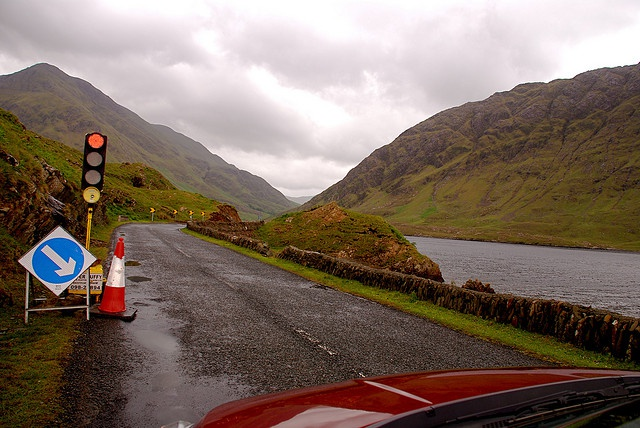Describe the objects in this image and their specific colors. I can see car in darkgray, maroon, black, brown, and gray tones and traffic light in darkgray, black, gray, and maroon tones in this image. 